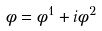<formula> <loc_0><loc_0><loc_500><loc_500>\phi = \phi ^ { 1 } + i \phi ^ { 2 }</formula> 